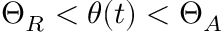Convert formula to latex. <formula><loc_0><loc_0><loc_500><loc_500>\Theta _ { R } < \theta ( t ) < \Theta _ { A }</formula> 